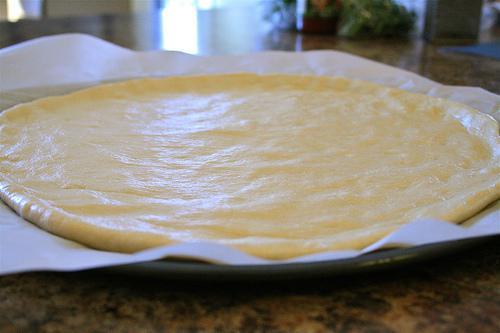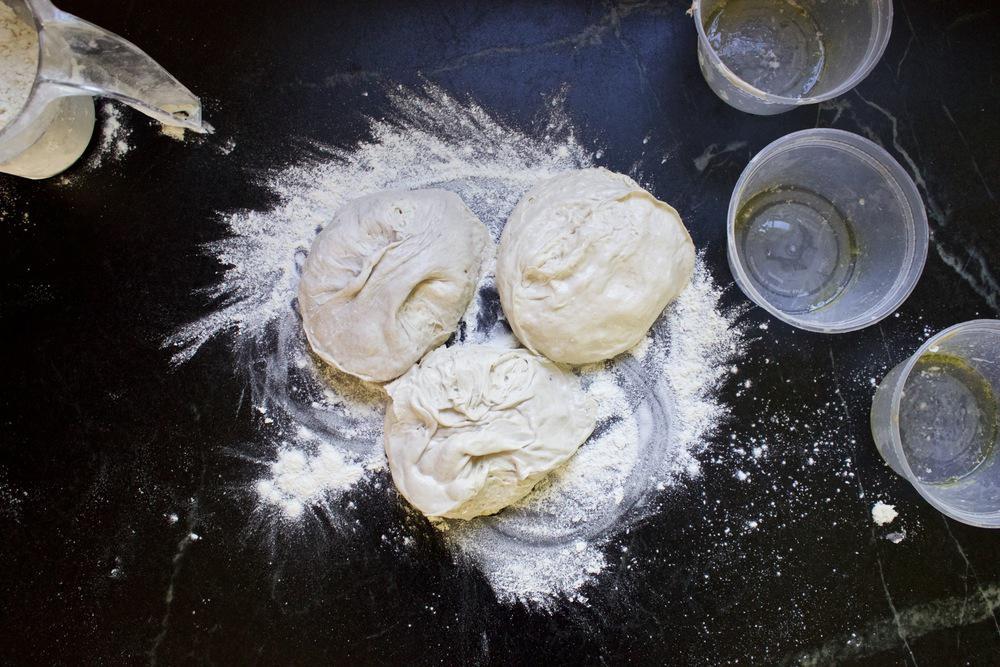The first image is the image on the left, the second image is the image on the right. Analyze the images presented: Is the assertion "At least one of the images shows dough proofing in a bowl." valid? Answer yes or no. No. The first image is the image on the left, the second image is the image on the right. Analyze the images presented: Is the assertion "Some of the dough is still in the mixing bowl." valid? Answer yes or no. No. 